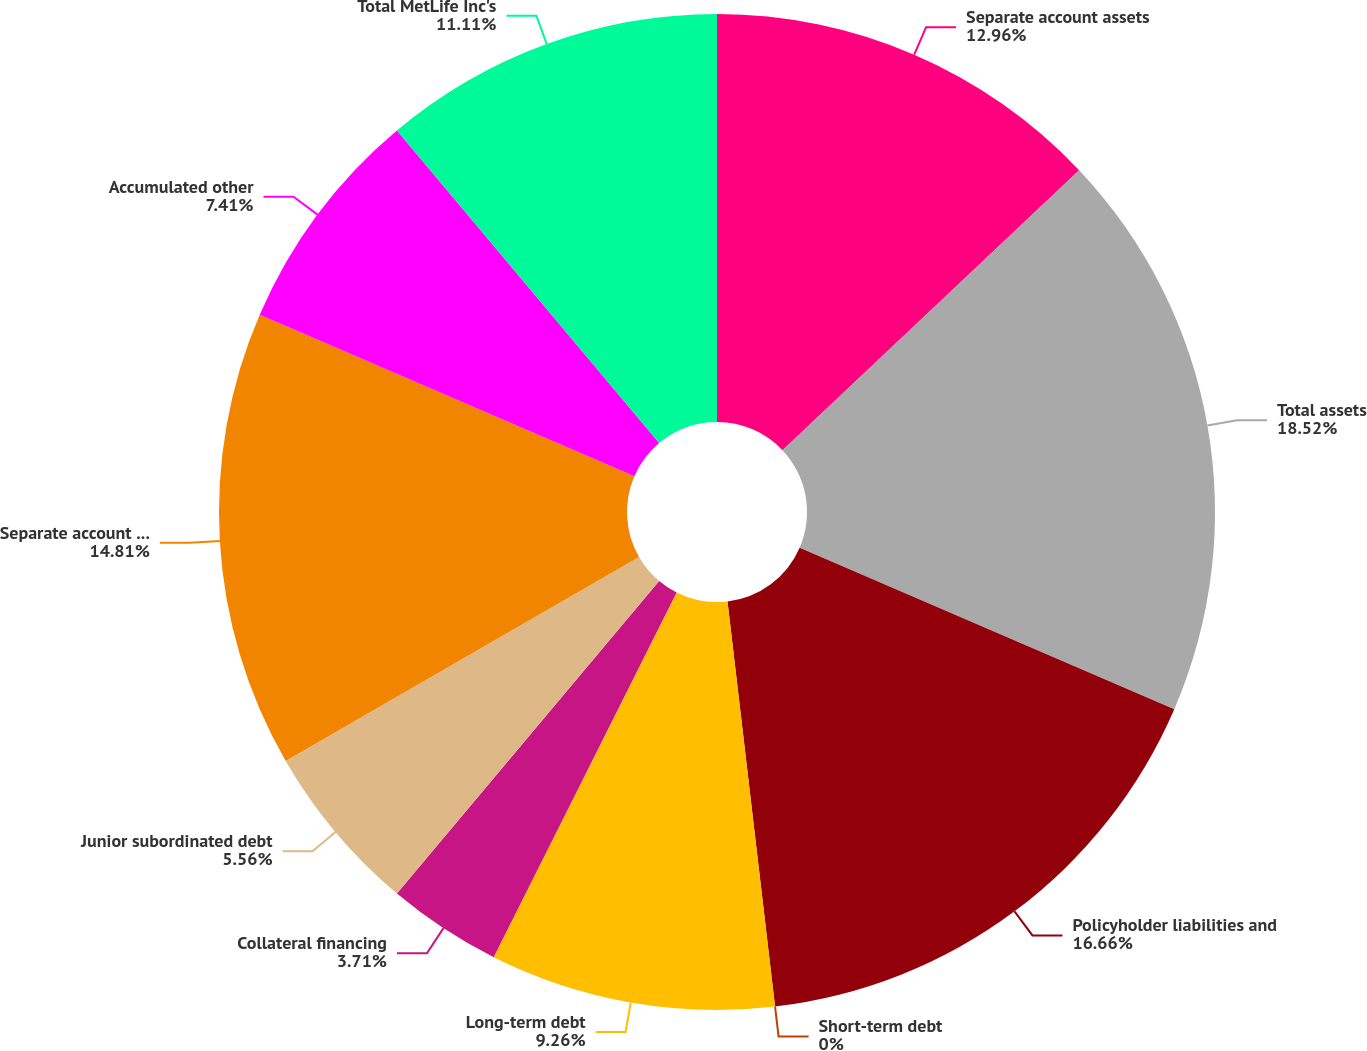Convert chart to OTSL. <chart><loc_0><loc_0><loc_500><loc_500><pie_chart><fcel>Separate account assets<fcel>Total assets<fcel>Policyholder liabilities and<fcel>Short-term debt<fcel>Long-term debt<fcel>Collateral financing<fcel>Junior subordinated debt<fcel>Separate account liabilities<fcel>Accumulated other<fcel>Total MetLife Inc's<nl><fcel>12.96%<fcel>18.52%<fcel>16.66%<fcel>0.0%<fcel>9.26%<fcel>3.71%<fcel>5.56%<fcel>14.81%<fcel>7.41%<fcel>11.11%<nl></chart> 